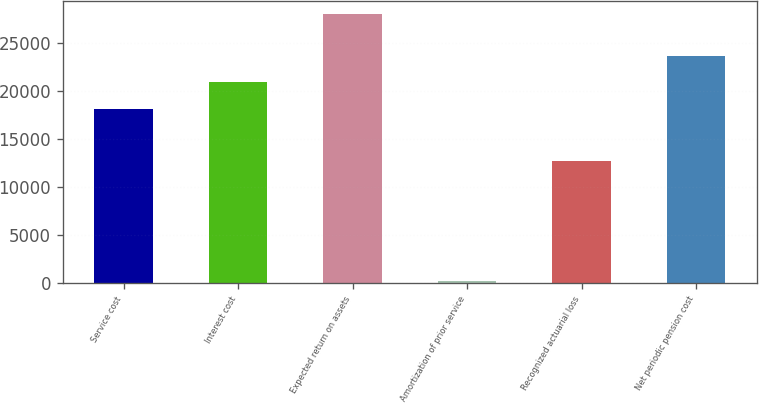Convert chart. <chart><loc_0><loc_0><loc_500><loc_500><bar_chart><fcel>Service cost<fcel>Interest cost<fcel>Expected return on assets<fcel>Amortization of prior service<fcel>Recognized actuarial loss<fcel>Net periodic pension cost<nl><fcel>18109<fcel>20883.4<fcel>27975<fcel>231<fcel>12744<fcel>23657.8<nl></chart> 